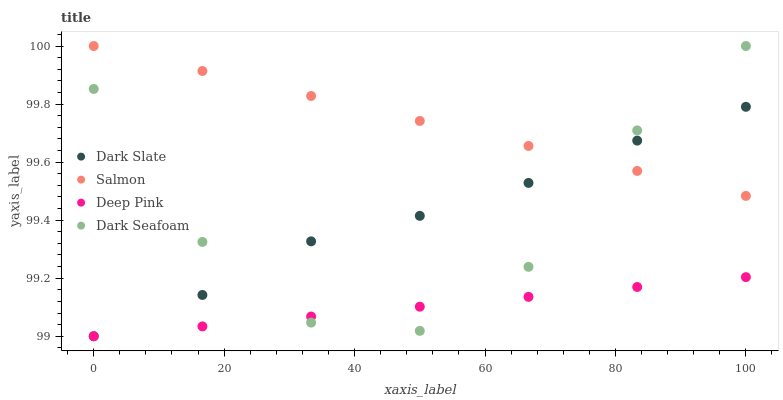Does Deep Pink have the minimum area under the curve?
Answer yes or no. Yes. Does Salmon have the maximum area under the curve?
Answer yes or no. Yes. Does Dark Seafoam have the minimum area under the curve?
Answer yes or no. No. Does Dark Seafoam have the maximum area under the curve?
Answer yes or no. No. Is Salmon the smoothest?
Answer yes or no. Yes. Is Dark Seafoam the roughest?
Answer yes or no. Yes. Is Deep Pink the smoothest?
Answer yes or no. No. Is Deep Pink the roughest?
Answer yes or no. No. Does Dark Slate have the lowest value?
Answer yes or no. Yes. Does Dark Seafoam have the lowest value?
Answer yes or no. No. Does Salmon have the highest value?
Answer yes or no. Yes. Does Deep Pink have the highest value?
Answer yes or no. No. Is Deep Pink less than Salmon?
Answer yes or no. Yes. Is Salmon greater than Deep Pink?
Answer yes or no. Yes. Does Salmon intersect Dark Seafoam?
Answer yes or no. Yes. Is Salmon less than Dark Seafoam?
Answer yes or no. No. Is Salmon greater than Dark Seafoam?
Answer yes or no. No. Does Deep Pink intersect Salmon?
Answer yes or no. No. 